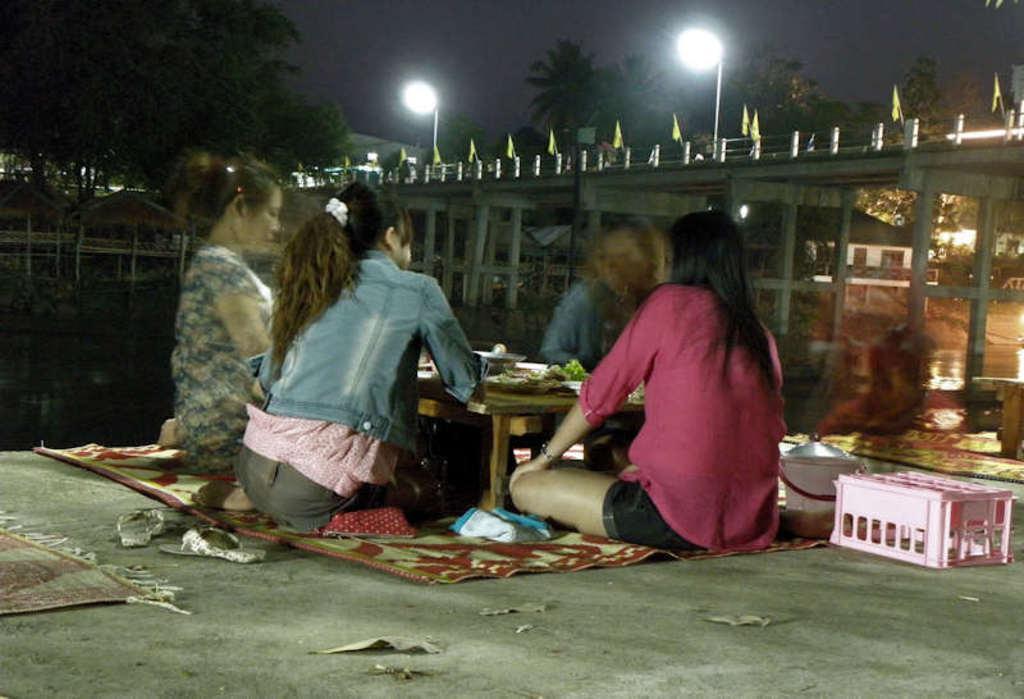Please provide a concise description of this image. In this image we can see few people sitting on the mat and there are some other objects on the floor and we can see a table with some objects in the middle. There is a bridge over the water and we can see some flags and there are some houses and trees in the background and at the top we can see the sky. 